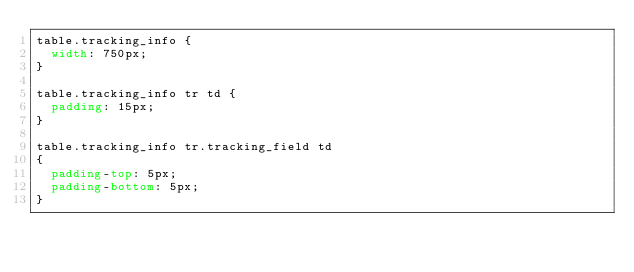<code> <loc_0><loc_0><loc_500><loc_500><_CSS_>table.tracking_info {
  width: 750px;
}

table.tracking_info tr td {
  padding: 15px;
}

table.tracking_info tr.tracking_field td
{
  padding-top: 5px;
  padding-bottom: 5px;
}
</code> 